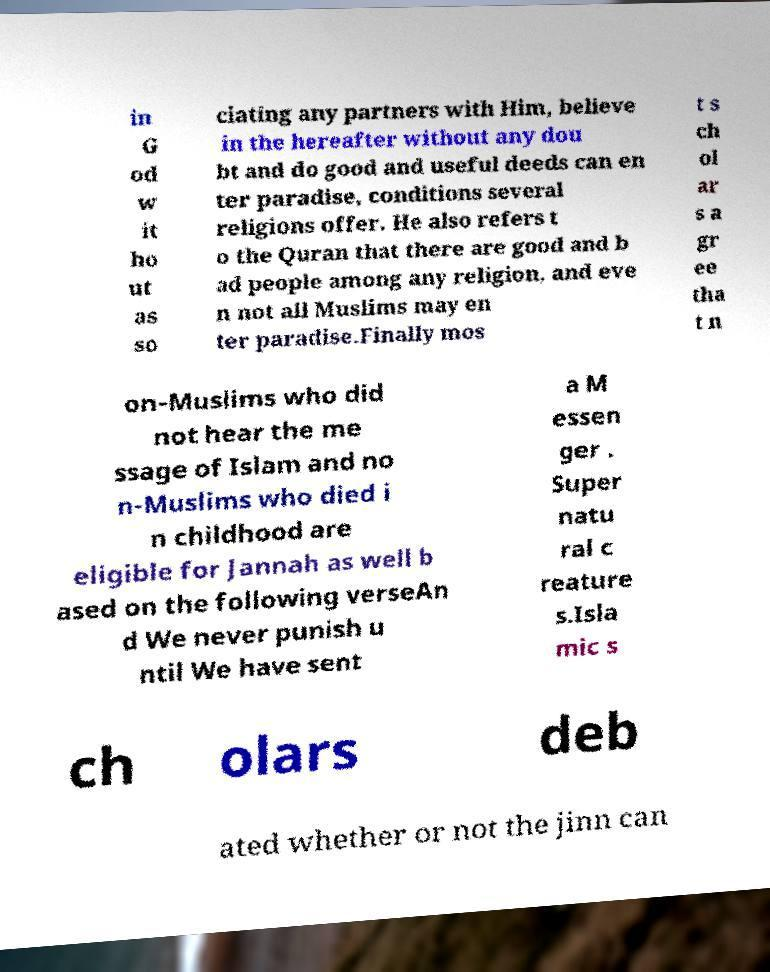What messages or text are displayed in this image? I need them in a readable, typed format. in G od w it ho ut as so ciating any partners with Him, believe in the hereafter without any dou bt and do good and useful deeds can en ter paradise, conditions several religions offer. He also refers t o the Quran that there are good and b ad people among any religion, and eve n not all Muslims may en ter paradise.Finally mos t s ch ol ar s a gr ee tha t n on-Muslims who did not hear the me ssage of Islam and no n-Muslims who died i n childhood are eligible for Jannah as well b ased on the following verseAn d We never punish u ntil We have sent a M essen ger . Super natu ral c reature s.Isla mic s ch olars deb ated whether or not the jinn can 